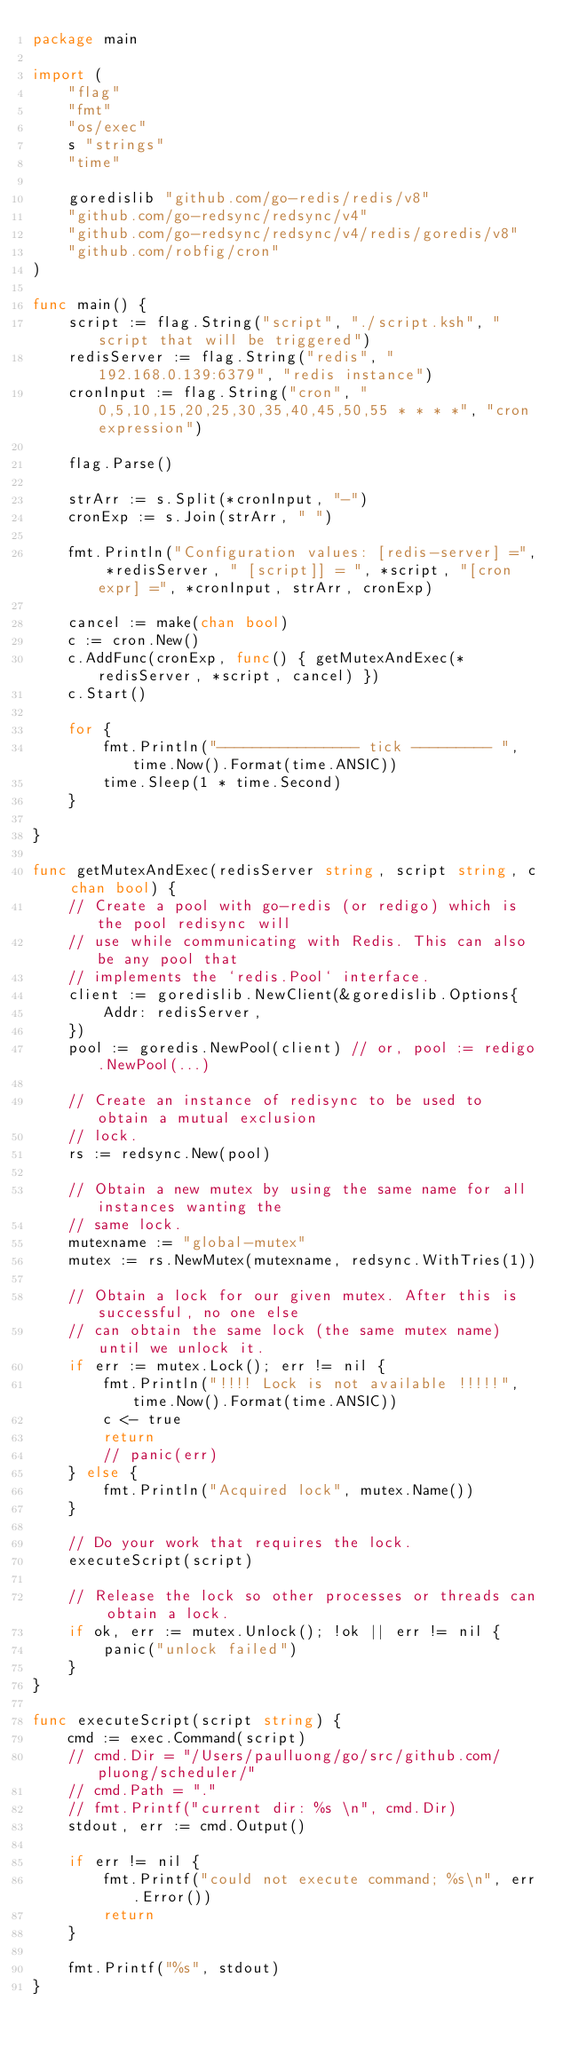<code> <loc_0><loc_0><loc_500><loc_500><_Go_>package main

import (
	"flag"
	"fmt"
	"os/exec"
	s "strings"
	"time"

	goredislib "github.com/go-redis/redis/v8"
	"github.com/go-redsync/redsync/v4"
	"github.com/go-redsync/redsync/v4/redis/goredis/v8"
	"github.com/robfig/cron"
)

func main() {
	script := flag.String("script", "./script.ksh", "script that will be triggered")
	redisServer := flag.String("redis", "192.168.0.139:6379", "redis instance")
	cronInput := flag.String("cron", "0,5,10,15,20,25,30,35,40,45,50,55 * * * *", "cron expression")

	flag.Parse()

	strArr := s.Split(*cronInput, "-")
	cronExp := s.Join(strArr, " ")

	fmt.Println("Configuration values: [redis-server] =", *redisServer, " [script]] = ", *script, "[cron expr] =", *cronInput, strArr, cronExp)

	cancel := make(chan bool)
	c := cron.New()
	c.AddFunc(cronExp, func() { getMutexAndExec(*redisServer, *script, cancel) })
	c.Start()

	for {
		fmt.Println("---------------- tick --------- ", time.Now().Format(time.ANSIC))
		time.Sleep(1 * time.Second)
	}

}

func getMutexAndExec(redisServer string, script string, c chan bool) {
	// Create a pool with go-redis (or redigo) which is the pool redisync will
	// use while communicating with Redis. This can also be any pool that
	// implements the `redis.Pool` interface.
	client := goredislib.NewClient(&goredislib.Options{
		Addr: redisServer,
	})
	pool := goredis.NewPool(client) // or, pool := redigo.NewPool(...)

	// Create an instance of redisync to be used to obtain a mutual exclusion
	// lock.
	rs := redsync.New(pool)

	// Obtain a new mutex by using the same name for all instances wanting the
	// same lock.
	mutexname := "global-mutex"
	mutex := rs.NewMutex(mutexname, redsync.WithTries(1))

	// Obtain a lock for our given mutex. After this is successful, no one else
	// can obtain the same lock (the same mutex name) until we unlock it.
	if err := mutex.Lock(); err != nil {
		fmt.Println("!!!! Lock is not available !!!!!", time.Now().Format(time.ANSIC))
		c <- true
		return
		// panic(err)
	} else {
		fmt.Println("Acquired lock", mutex.Name())
	}

	// Do your work that requires the lock.
	executeScript(script)

	// Release the lock so other processes or threads can obtain a lock.
	if ok, err := mutex.Unlock(); !ok || err != nil {
		panic("unlock failed")
	}
}

func executeScript(script string) {
	cmd := exec.Command(script)
	// cmd.Dir = "/Users/paulluong/go/src/github.com/pluong/scheduler/"
	// cmd.Path = "."
	// fmt.Printf("current dir: %s \n", cmd.Dir)
	stdout, err := cmd.Output()

	if err != nil {
		fmt.Printf("could not execute command; %s\n", err.Error())
		return
	}

	fmt.Printf("%s", stdout)
}
</code> 